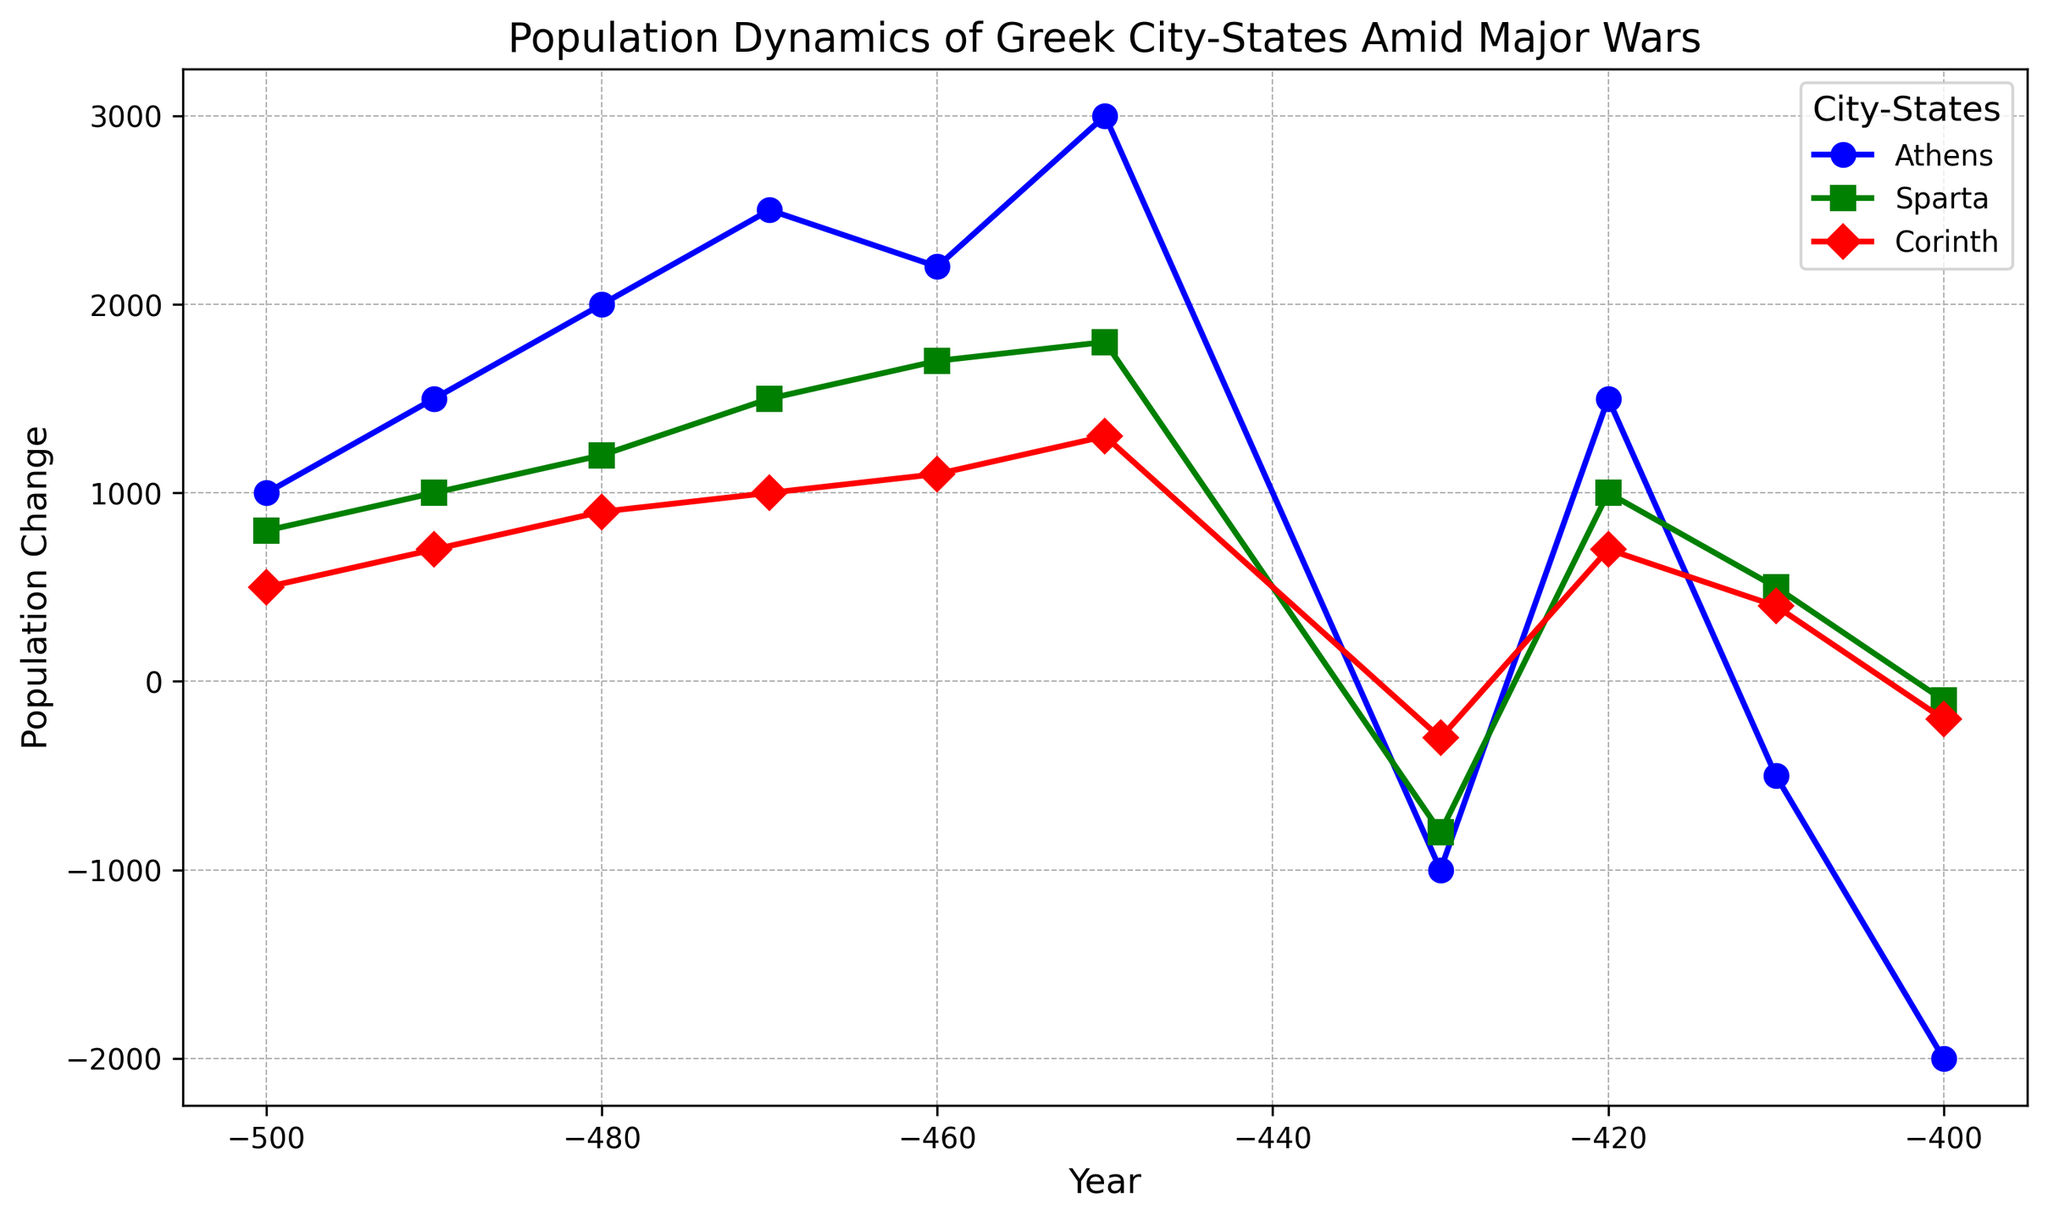What's the general trend of population changes in Athens around 430 BC? Around 430 BC, Athens experienced a sharp decline in population followed by fluctuations. Specifically, population decreased significantly at 430 BC, and then it rebounded in 420 BC, only to drop again in the subsequent years.
Answer: Sharp decline followed by fluctuations Between Athens, Sparta, and Corinth, which city-state had the most stable population change from 450 BC to 400 BC? By examining the population changes for each city-state between 450 BC to 400 BC, we see that Corinth has fewer extreme changes compared to Athens and Sparta, indicating more stability. Athens and Sparta both experience significant declines, whereas Corinth has smaller changes.
Answer: Corinth Which city-state had the highest population change peak and in what year? By comparing the peaks in the graph, we see that Athens had the highest peak population change, at 3000, in the year 450 BC. This is higher than the peaks of either Sparta or Corinth.
Answer: Athens in 450 BC What is the overall population change trend for Sparta from 500 BC to 400 BC? From 500 BC to 400 BC, Sparta shows an overall increasing trend in population changes until 450 BC, then a significant dip at 430 BC, slightly rebounding afterward and leveling out.
Answer: Overall increasing, then dip, and leveling out During which decade did Corinth experience its largest population decline? By observing the population change of Corinth, we notice the steepest decline happens between 450 BC and 430 BC. Specifically, the biggest negative change occurs around 430 BC.
Answer: 430 BC-420 BC Compare and contrast the population trends of Sparta and Athens from 470 BC to 400 BC. In this period, both Athens and Sparta see an overall increase in population until 450 BC. Afterward, Athens experiences major fluctuations with a significant decline around 400 BC, whereas Sparta also declines but less drastically, showing smaller fluctuations.
Answer: Athens fluctuated drastically; Sparta fluctuated less What can you infer about the possible impact of wars on the population dynamics of Athens? The population changes in Athens have sharp declines around 430 BC and 400 BC, which might correspond to the periods of the Peloponnesian War, indicating significant population reductions likely due to war impacts.
Answer: Major wars likely caused sharp population declines Which city-state had the highest positive population change in 420 BC and by how much? In the year 420 BC, by referring to the individual data points for each city-state, Athens had the highest positive population change of 1500, compared to Sparta and Corinth.
Answer: Athens, by 1500 What is the average population change for Athens from 500 BC to 400 BC? To find the average, sum the population changes for Athens from 500 BC to 400 BC (1000 + 1500 + 2000 + 2500 + 2200 + 3000 - 1000 + 1500 - 500 - 2000 = 12200). Then, divide by the number of data points (10). The average is 1220.
Answer: 1220 